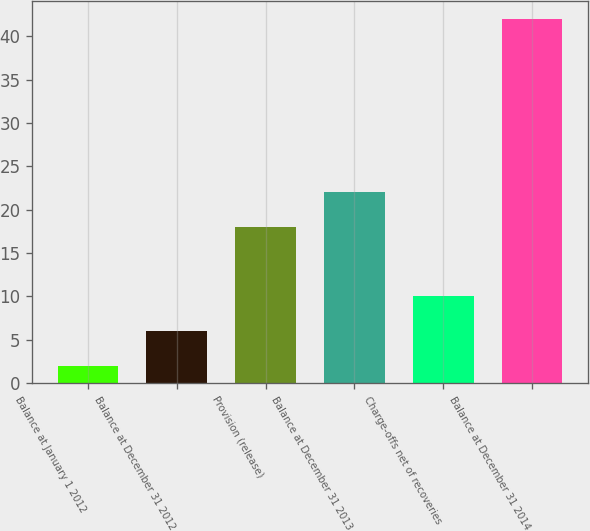Convert chart to OTSL. <chart><loc_0><loc_0><loc_500><loc_500><bar_chart><fcel>Balance at January 1 2012<fcel>Balance at December 31 2012<fcel>Provision (release)<fcel>Balance at December 31 2013<fcel>Charge-offs net of recoveries<fcel>Balance at December 31 2014<nl><fcel>2<fcel>6<fcel>18<fcel>22<fcel>10<fcel>42<nl></chart> 